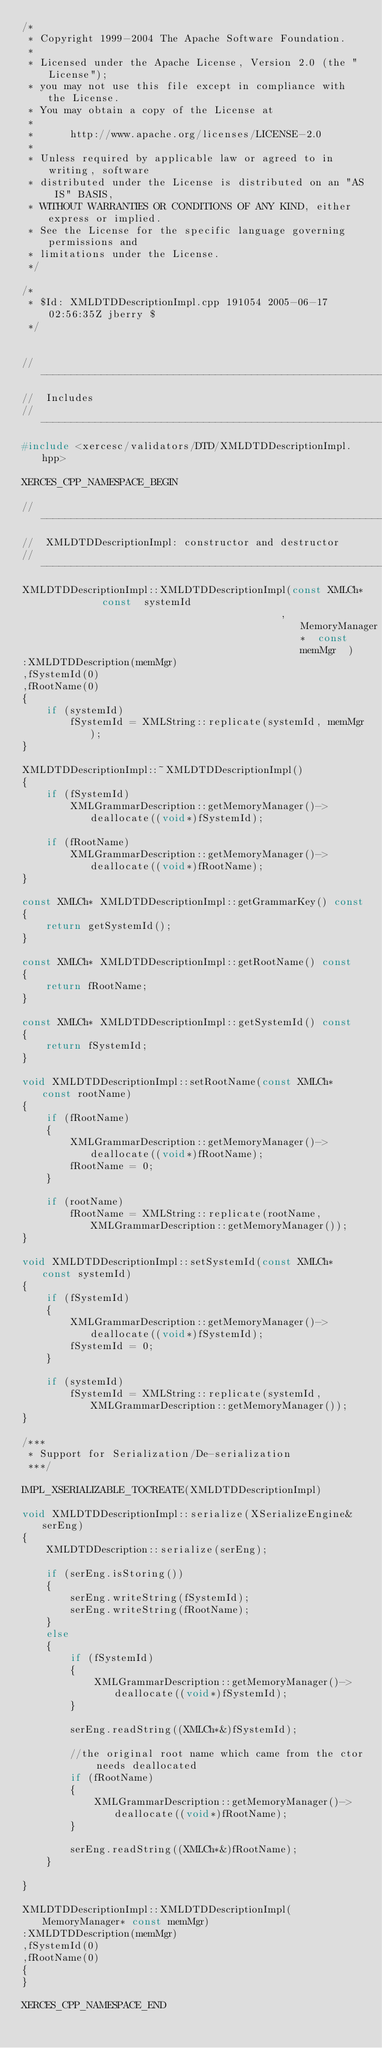<code> <loc_0><loc_0><loc_500><loc_500><_C++_>/*
 * Copyright 1999-2004 The Apache Software Foundation.
 * 
 * Licensed under the Apache License, Version 2.0 (the "License");
 * you may not use this file except in compliance with the License.
 * You may obtain a copy of the License at
 * 
 *      http://www.apache.org/licenses/LICENSE-2.0
 * 
 * Unless required by applicable law or agreed to in writing, software
 * distributed under the License is distributed on an "AS IS" BASIS,
 * WITHOUT WARRANTIES OR CONDITIONS OF ANY KIND, either express or implied.
 * See the License for the specific language governing permissions and
 * limitations under the License.
 */

/*
 * $Id: XMLDTDDescriptionImpl.cpp 191054 2005-06-17 02:56:35Z jberry $
 */


// ---------------------------------------------------------------------------
//  Includes
// ---------------------------------------------------------------------------
#include <xercesc/validators/DTD/XMLDTDDescriptionImpl.hpp>

XERCES_CPP_NAMESPACE_BEGIN

// ---------------------------------------------------------------------------
//  XMLDTDDescriptionImpl: constructor and destructor
// ---------------------------------------------------------------------------
XMLDTDDescriptionImpl::XMLDTDDescriptionImpl(const XMLCh*          const  systemId
                                           ,       MemoryManager*  const  memMgr  )
:XMLDTDDescription(memMgr)
,fSystemId(0)
,fRootName(0)
{
    if (systemId)
        fSystemId = XMLString::replicate(systemId, memMgr);
}

XMLDTDDescriptionImpl::~XMLDTDDescriptionImpl()
{
    if (fSystemId)
        XMLGrammarDescription::getMemoryManager()->deallocate((void*)fSystemId);

    if (fRootName)
        XMLGrammarDescription::getMemoryManager()->deallocate((void*)fRootName);
}
             
const XMLCh* XMLDTDDescriptionImpl::getGrammarKey() const
{
    return getSystemId();
}
              
const XMLCh* XMLDTDDescriptionImpl::getRootName() const
{ 
    return fRootName; 
}

const XMLCh* XMLDTDDescriptionImpl::getSystemId() const
{ 
    return fSystemId; 
}

void XMLDTDDescriptionImpl::setRootName(const XMLCh* const rootName)
{
    if (fRootName)
    {
        XMLGrammarDescription::getMemoryManager()->deallocate((void*)fRootName);
        fRootName = 0;
    }

    if (rootName)
        fRootName = XMLString::replicate(rootName, XMLGrammarDescription::getMemoryManager()); 
}        

void XMLDTDDescriptionImpl::setSystemId(const XMLCh* const systemId)
{
    if (fSystemId)
    {
        XMLGrammarDescription::getMemoryManager()->deallocate((void*)fSystemId);
        fSystemId = 0;
    }

    if (systemId)
        fSystemId = XMLString::replicate(systemId, XMLGrammarDescription::getMemoryManager()); 
}        

/***
 * Support for Serialization/De-serialization
 ***/

IMPL_XSERIALIZABLE_TOCREATE(XMLDTDDescriptionImpl)

void XMLDTDDescriptionImpl::serialize(XSerializeEngine& serEng)
{
    XMLDTDDescription::serialize(serEng);

    if (serEng.isStoring())
    {
        serEng.writeString(fSystemId);
        serEng.writeString(fRootName);
    }
    else
    {
        if (fSystemId)
        {
            XMLGrammarDescription::getMemoryManager()->deallocate((void*)fSystemId);
        }

        serEng.readString((XMLCh*&)fSystemId);

        //the original root name which came from the ctor needs deallocated
        if (fRootName)
        {
            XMLGrammarDescription::getMemoryManager()->deallocate((void*)fRootName);
        }

        serEng.readString((XMLCh*&)fRootName);
    }

}

XMLDTDDescriptionImpl::XMLDTDDescriptionImpl(MemoryManager* const memMgr)
:XMLDTDDescription(memMgr)
,fSystemId(0)
,fRootName(0)
{
}

XERCES_CPP_NAMESPACE_END
</code> 